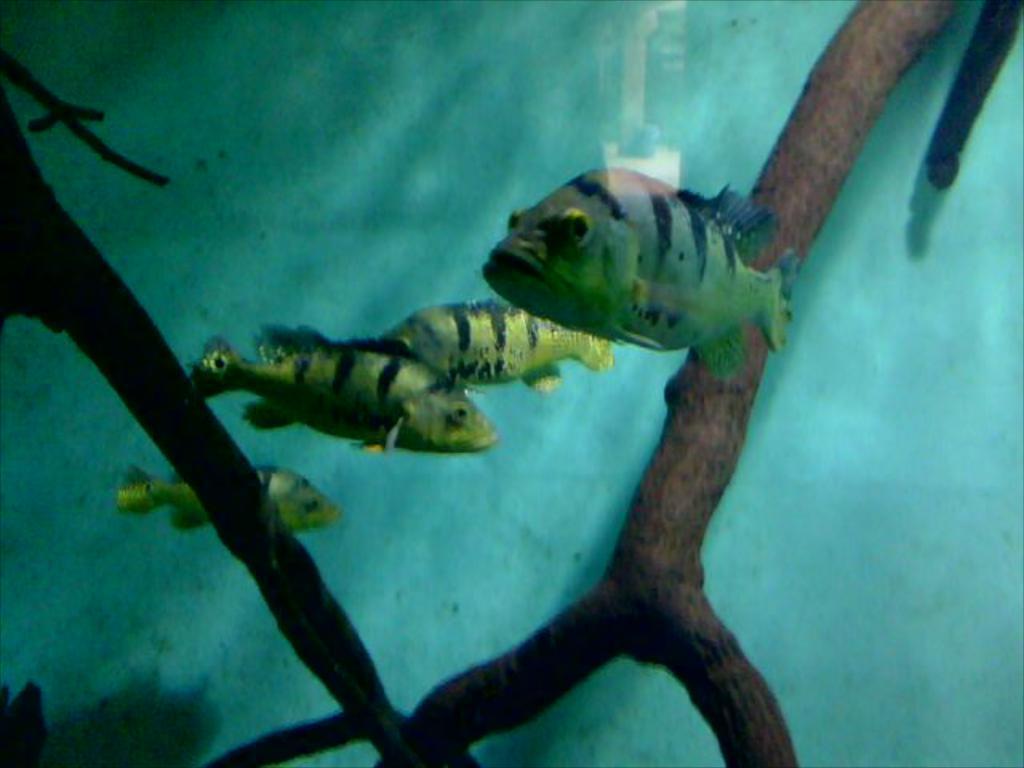How would you summarize this image in a sentence or two? In the picture I can see fishes in the water. There are four fishes in the water. I can also see plants. 